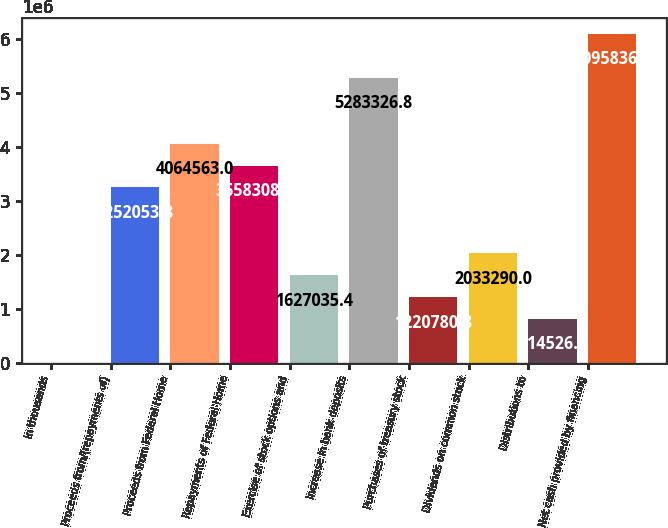<chart> <loc_0><loc_0><loc_500><loc_500><bar_chart><fcel>in thousands<fcel>Proceeds from/(repayments of)<fcel>Proceeds from Federal Home<fcel>Repayments of Federal Home<fcel>Exercise of stock options and<fcel>Increase in bank deposits<fcel>Purchases of treasury stock<fcel>Dividends on common stock<fcel>Distributions to<fcel>Net cash provided by financing<nl><fcel>2017<fcel>3.25205e+06<fcel>4.06456e+06<fcel>3.65831e+06<fcel>1.62704e+06<fcel>5.28333e+06<fcel>1.22078e+06<fcel>2.03329e+06<fcel>814526<fcel>6.09584e+06<nl></chart> 